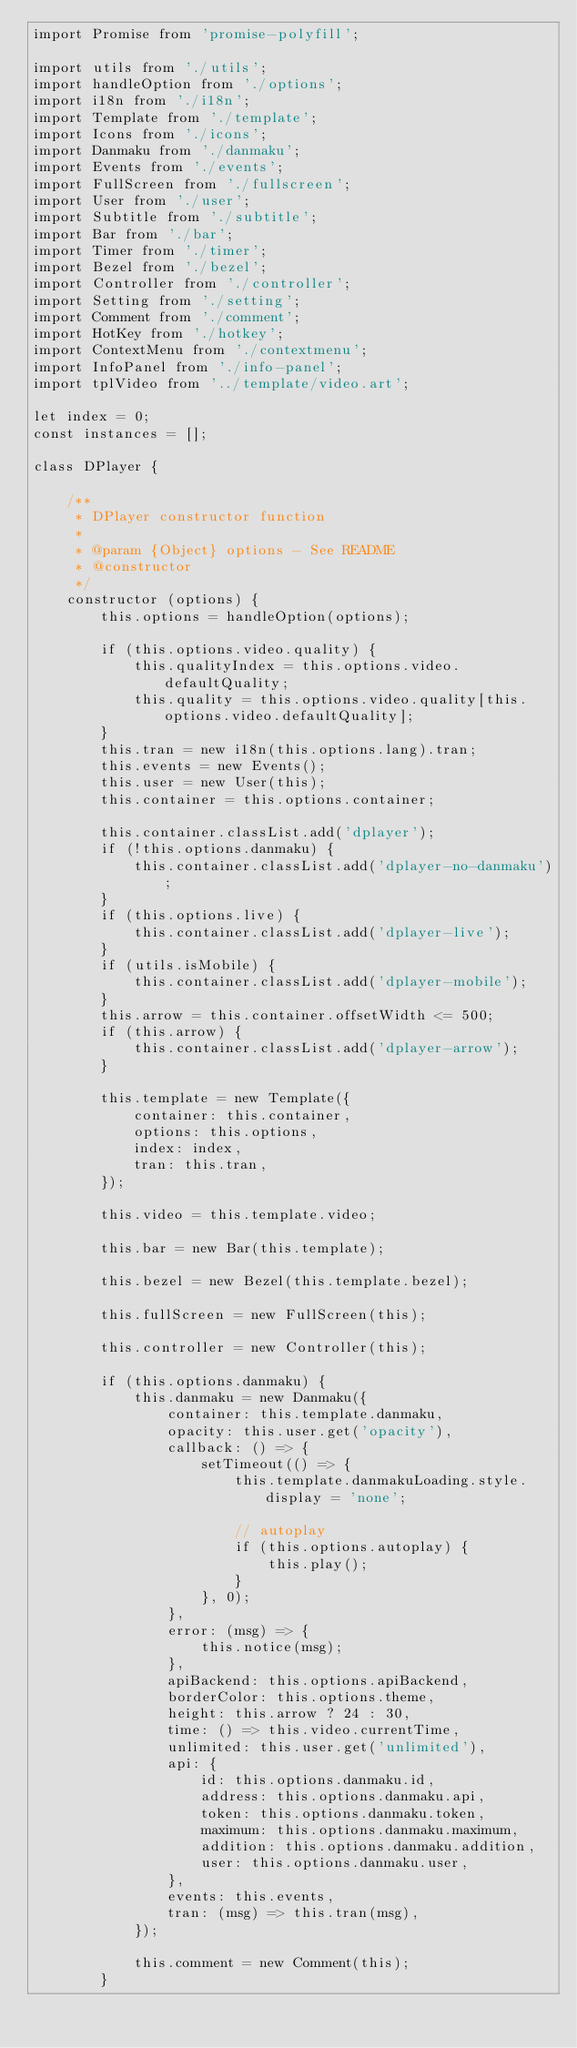<code> <loc_0><loc_0><loc_500><loc_500><_JavaScript_>import Promise from 'promise-polyfill';

import utils from './utils';
import handleOption from './options';
import i18n from './i18n';
import Template from './template';
import Icons from './icons';
import Danmaku from './danmaku';
import Events from './events';
import FullScreen from './fullscreen';
import User from './user';
import Subtitle from './subtitle';
import Bar from './bar';
import Timer from './timer';
import Bezel from './bezel';
import Controller from './controller';
import Setting from './setting';
import Comment from './comment';
import HotKey from './hotkey';
import ContextMenu from './contextmenu';
import InfoPanel from './info-panel';
import tplVideo from '../template/video.art';

let index = 0;
const instances = [];

class DPlayer {

    /**
     * DPlayer constructor function
     *
     * @param {Object} options - See README
     * @constructor
     */
    constructor (options) {
        this.options = handleOption(options);

        if (this.options.video.quality) {
            this.qualityIndex = this.options.video.defaultQuality;
            this.quality = this.options.video.quality[this.options.video.defaultQuality];
        }
        this.tran = new i18n(this.options.lang).tran;
        this.events = new Events();
        this.user = new User(this);
        this.container = this.options.container;

        this.container.classList.add('dplayer');
        if (!this.options.danmaku) {
            this.container.classList.add('dplayer-no-danmaku');
        }
        if (this.options.live) {
            this.container.classList.add('dplayer-live');
        }
        if (utils.isMobile) {
            this.container.classList.add('dplayer-mobile');
        }
        this.arrow = this.container.offsetWidth <= 500;
        if (this.arrow) {
            this.container.classList.add('dplayer-arrow');
        }

        this.template = new Template({
            container: this.container,
            options: this.options,
            index: index,
            tran: this.tran,
        });

        this.video = this.template.video;

        this.bar = new Bar(this.template);

        this.bezel = new Bezel(this.template.bezel);

        this.fullScreen = new FullScreen(this);

        this.controller = new Controller(this);

        if (this.options.danmaku) {
            this.danmaku = new Danmaku({
                container: this.template.danmaku,
                opacity: this.user.get('opacity'),
                callback: () => {
                    setTimeout(() => {
                        this.template.danmakuLoading.style.display = 'none';

                        // autoplay
                        if (this.options.autoplay) {
                            this.play();
                        }
                    }, 0);
                },
                error: (msg) => {
                    this.notice(msg);
                },
                apiBackend: this.options.apiBackend,
                borderColor: this.options.theme,
                height: this.arrow ? 24 : 30,
                time: () => this.video.currentTime,
                unlimited: this.user.get('unlimited'),
                api: {
                    id: this.options.danmaku.id,
                    address: this.options.danmaku.api,
                    token: this.options.danmaku.token,
                    maximum: this.options.danmaku.maximum,
                    addition: this.options.danmaku.addition,
                    user: this.options.danmaku.user,
                },
                events: this.events,
                tran: (msg) => this.tran(msg),
            });

            this.comment = new Comment(this);
        }
</code> 